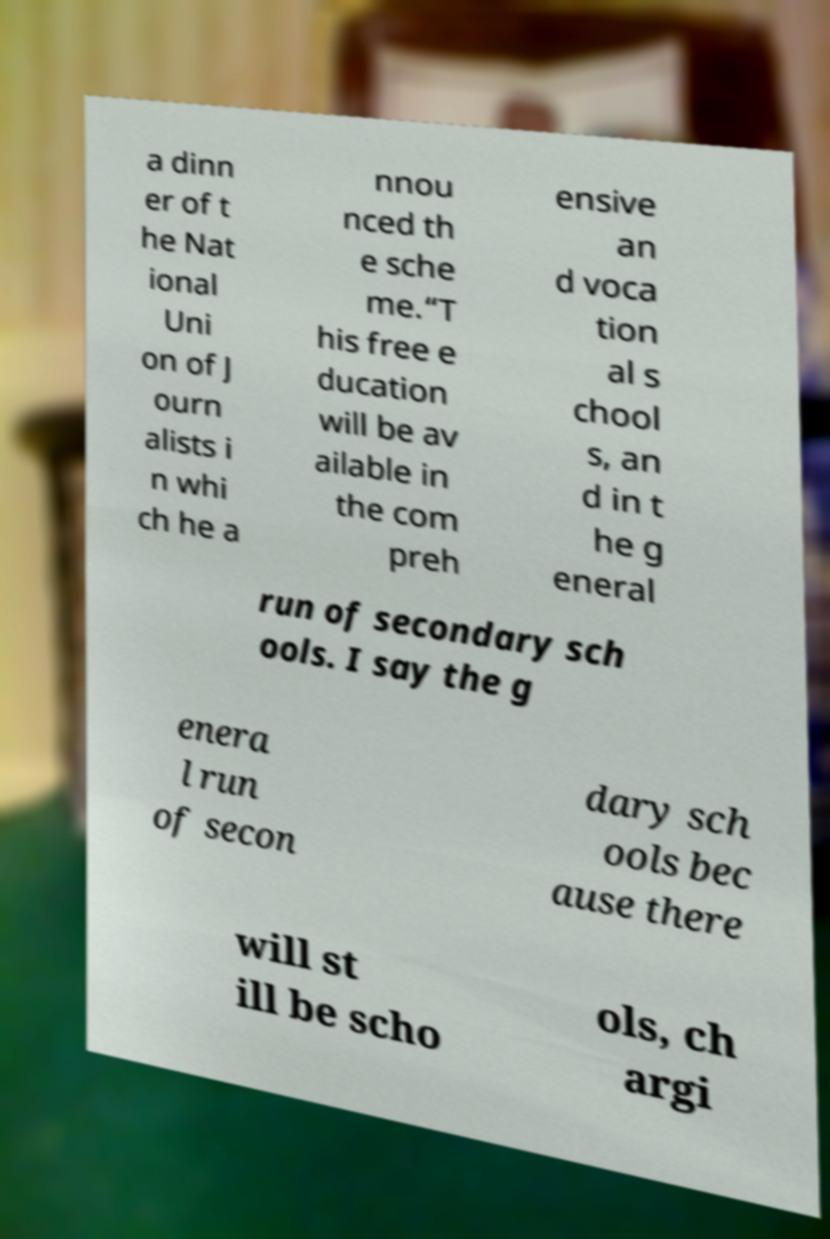I need the written content from this picture converted into text. Can you do that? a dinn er of t he Nat ional Uni on of J ourn alists i n whi ch he a nnou nced th e sche me.“T his free e ducation will be av ailable in the com preh ensive an d voca tion al s chool s, an d in t he g eneral run of secondary sch ools. I say the g enera l run of secon dary sch ools bec ause there will st ill be scho ols, ch argi 